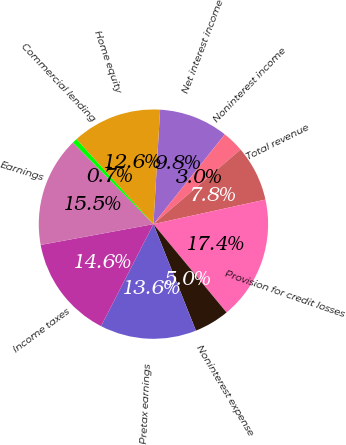<chart> <loc_0><loc_0><loc_500><loc_500><pie_chart><fcel>Net interest income<fcel>Noninterest income<fcel>Total revenue<fcel>Provision for credit losses<fcel>Noninterest expense<fcel>Pretax earnings<fcel>Income taxes<fcel>Earnings<fcel>Commercial lending<fcel>Home equity<nl><fcel>9.76%<fcel>3.04%<fcel>7.84%<fcel>17.43%<fcel>4.96%<fcel>13.59%<fcel>14.55%<fcel>15.51%<fcel>0.69%<fcel>12.63%<nl></chart> 